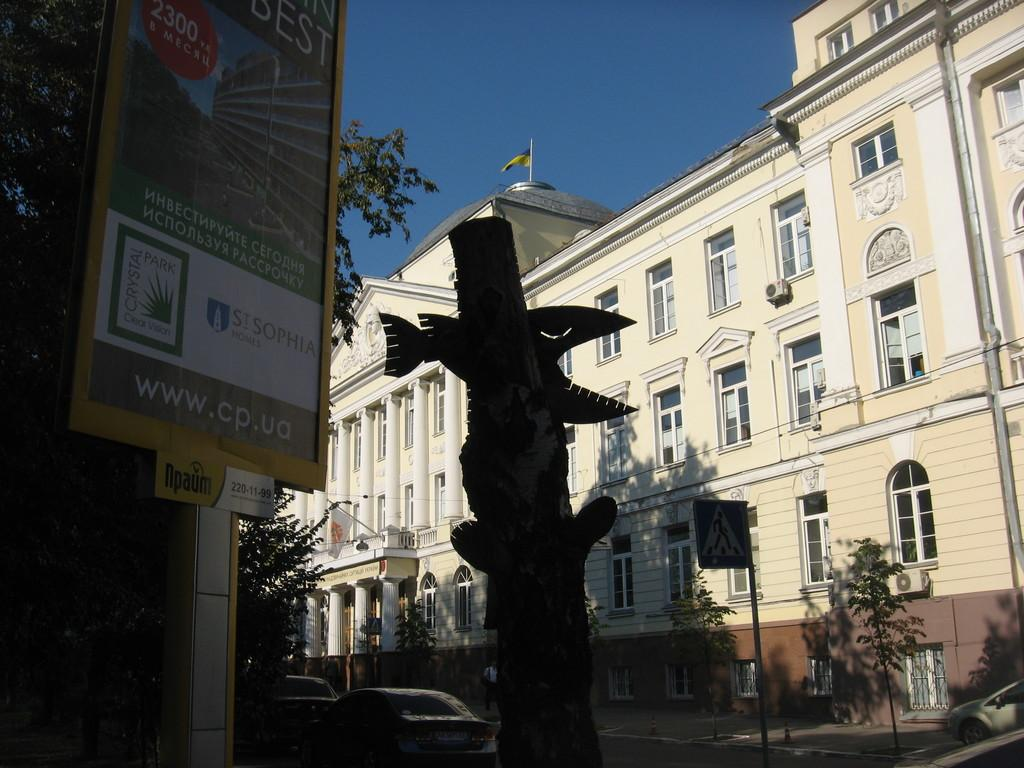What is the main structure in the center of the image? There is a building in the center of the image. What can be seen on the left side of the image? There is a board on the left side of the image. What type of vehicles are visible at the bottom of the image? Cars are visible at the bottom of the image. What type of natural elements are present in the image? Trees are present in the image. What is visible at the top of the image? The sky is visible at the top of the image. What type of mitten is being used to measure the value of the spring in the image? There is no mitten, measurement, or spring present in the image. 